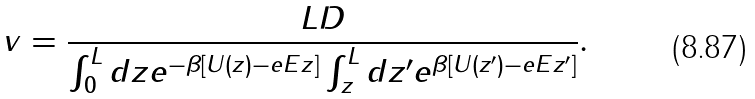<formula> <loc_0><loc_0><loc_500><loc_500>v = \frac { L D } { \int _ { 0 } ^ { L } d z e ^ { - \beta [ U ( z ) - e E z ] } \int _ { z } ^ { L } d z ^ { \prime } e ^ { \beta [ U ( z ^ { \prime } ) - e E z ^ { \prime } ] } } .</formula> 